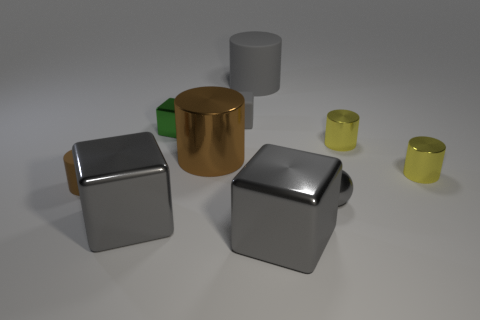Is the material of the tiny gray object that is behind the ball the same as the large brown cylinder?
Offer a very short reply. No. How many gray metal things are the same size as the green block?
Give a very brief answer. 1. Is the number of tiny shiny cylinders that are right of the big gray rubber cylinder greater than the number of small brown matte cylinders that are right of the big shiny cylinder?
Your answer should be compact. Yes. Are there any large metal objects of the same shape as the small brown matte thing?
Give a very brief answer. Yes. How big is the metallic cylinder in front of the large cylinder that is to the left of the small rubber cube?
Your response must be concise. Small. What shape is the big shiny thing behind the gray object to the right of the large gray metal block that is to the right of the tiny green object?
Offer a very short reply. Cylinder. What size is the brown object that is the same material as the small sphere?
Your response must be concise. Large. Are there more gray metal things than small yellow metal cylinders?
Give a very brief answer. Yes. There is a gray cube that is the same size as the green block; what is it made of?
Your response must be concise. Rubber. There is a shiny cube on the left side of the green block; is its size the same as the small matte cylinder?
Provide a short and direct response. No. 